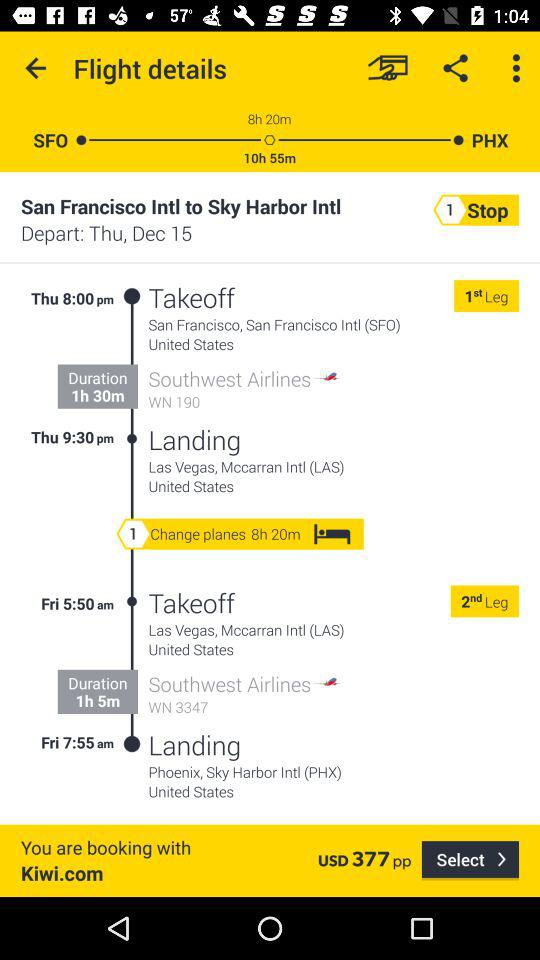What is the destination city? The destination city is Phoenix. 